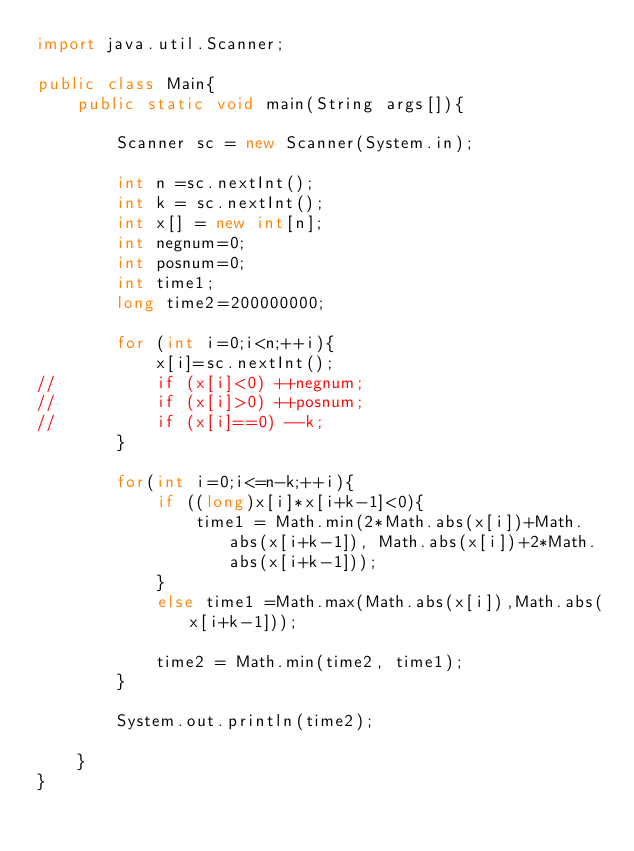Convert code to text. <code><loc_0><loc_0><loc_500><loc_500><_Java_>import java.util.Scanner;

public class Main{
	public static void main(String args[]){

		Scanner sc = new Scanner(System.in);

		int n =sc.nextInt();
		int k = sc.nextInt();
		int x[] = new int[n];
		int negnum=0;
		int posnum=0;
		int time1;
		long time2=200000000;

		for (int i=0;i<n;++i){
			x[i]=sc.nextInt();
//			if (x[i]<0) ++negnum;
//			if (x[i]>0) ++posnum;
//			if (x[i]==0) --k;
		}

		for(int i=0;i<=n-k;++i){
			if ((long)x[i]*x[i+k-1]<0){
				time1 = Math.min(2*Math.abs(x[i])+Math.abs(x[i+k-1]), Math.abs(x[i])+2*Math.abs(x[i+k-1]));
			}
			else time1 =Math.max(Math.abs(x[i]),Math.abs(x[i+k-1]));

			time2 = Math.min(time2, time1);
		}

		System.out.println(time2);

	}
}</code> 